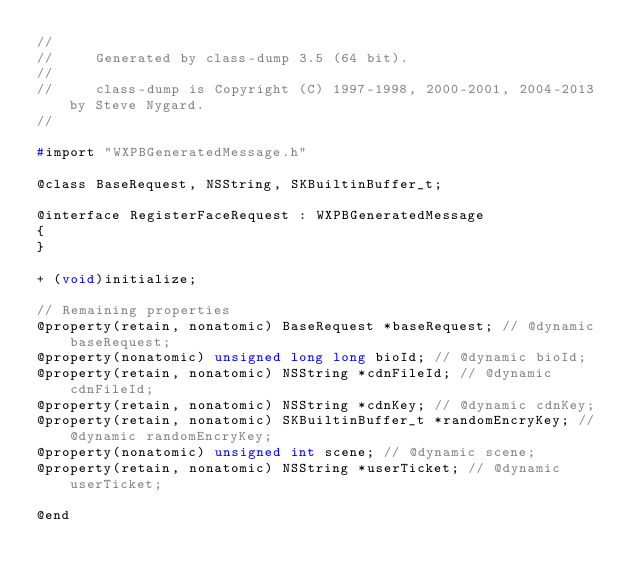<code> <loc_0><loc_0><loc_500><loc_500><_C_>//
//     Generated by class-dump 3.5 (64 bit).
//
//     class-dump is Copyright (C) 1997-1998, 2000-2001, 2004-2013 by Steve Nygard.
//

#import "WXPBGeneratedMessage.h"

@class BaseRequest, NSString, SKBuiltinBuffer_t;

@interface RegisterFaceRequest : WXPBGeneratedMessage
{
}

+ (void)initialize;

// Remaining properties
@property(retain, nonatomic) BaseRequest *baseRequest; // @dynamic baseRequest;
@property(nonatomic) unsigned long long bioId; // @dynamic bioId;
@property(retain, nonatomic) NSString *cdnFileId; // @dynamic cdnFileId;
@property(retain, nonatomic) NSString *cdnKey; // @dynamic cdnKey;
@property(retain, nonatomic) SKBuiltinBuffer_t *randomEncryKey; // @dynamic randomEncryKey;
@property(nonatomic) unsigned int scene; // @dynamic scene;
@property(retain, nonatomic) NSString *userTicket; // @dynamic userTicket;

@end

</code> 